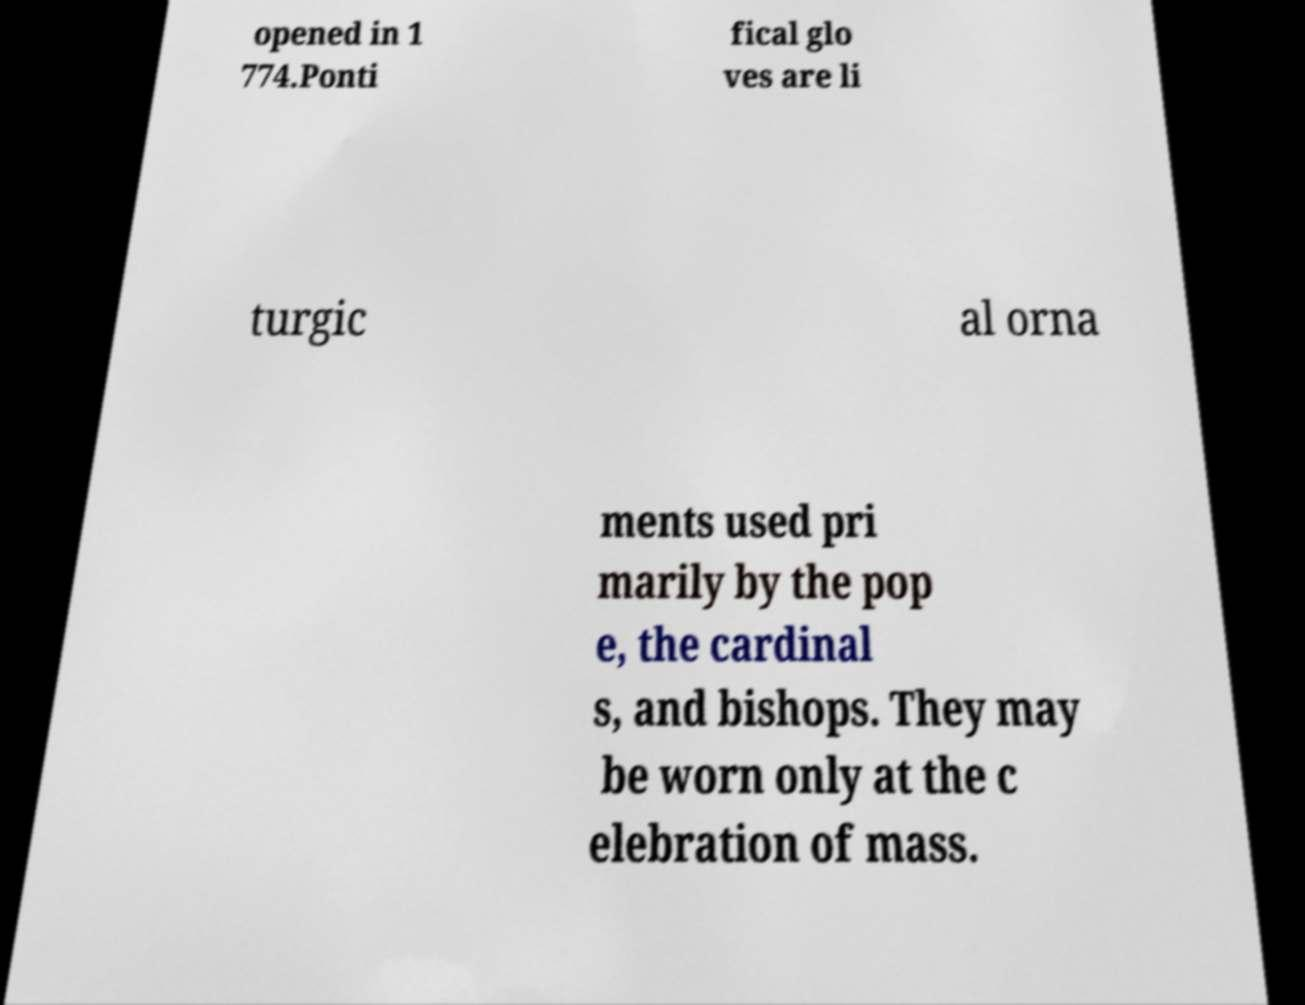What messages or text are displayed in this image? I need them in a readable, typed format. opened in 1 774.Ponti fical glo ves are li turgic al orna ments used pri marily by the pop e, the cardinal s, and bishops. They may be worn only at the c elebration of mass. 